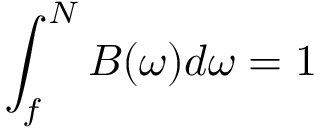<formula> <loc_0><loc_0><loc_500><loc_500>\int _ { f } ^ { N } B ( \omega ) d \omega = 1</formula> 